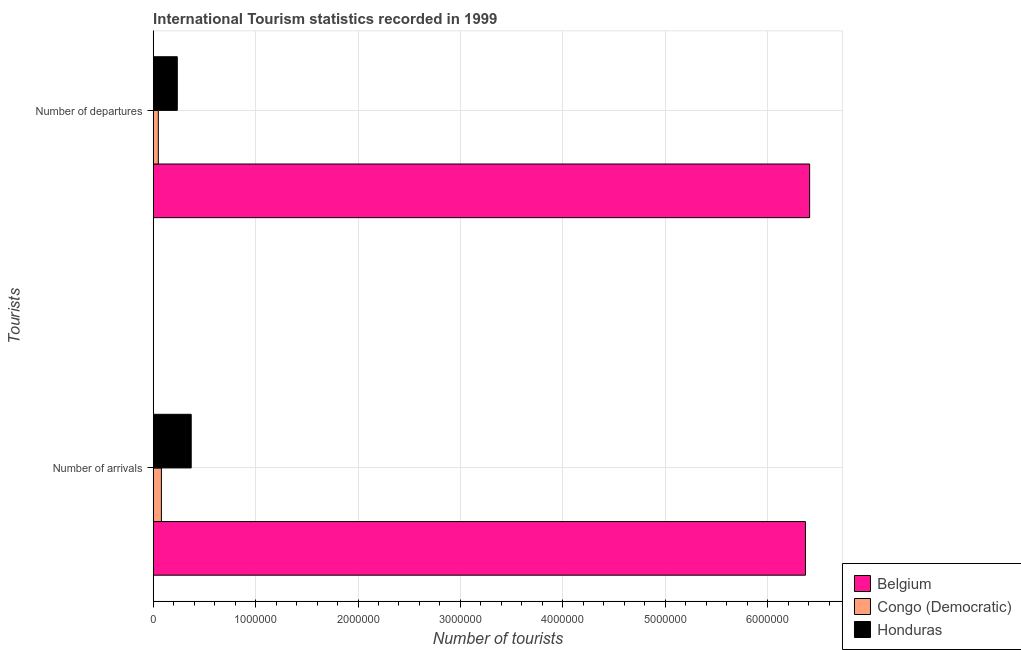How many bars are there on the 2nd tick from the top?
Offer a terse response. 3. What is the label of the 1st group of bars from the top?
Offer a very short reply. Number of departures. What is the number of tourist arrivals in Belgium?
Give a very brief answer. 6.37e+06. Across all countries, what is the maximum number of tourist arrivals?
Give a very brief answer. 6.37e+06. Across all countries, what is the minimum number of tourist departures?
Your answer should be compact. 5.00e+04. In which country was the number of tourist arrivals maximum?
Offer a very short reply. Belgium. In which country was the number of tourist departures minimum?
Ensure brevity in your answer.  Congo (Democratic). What is the total number of tourist departures in the graph?
Provide a succinct answer. 6.70e+06. What is the difference between the number of tourist arrivals in Congo (Democratic) and that in Belgium?
Keep it short and to the point. -6.29e+06. What is the difference between the number of tourist arrivals in Congo (Democratic) and the number of tourist departures in Belgium?
Keep it short and to the point. -6.33e+06. What is the average number of tourist departures per country?
Your answer should be very brief. 2.23e+06. What is the difference between the number of tourist departures and number of tourist arrivals in Congo (Democratic)?
Provide a short and direct response. -3.00e+04. In how many countries, is the number of tourist departures greater than 200000 ?
Offer a very short reply. 2. What is the ratio of the number of tourist arrivals in Congo (Democratic) to that in Belgium?
Make the answer very short. 0.01. Is the number of tourist arrivals in Honduras less than that in Belgium?
Offer a terse response. Yes. What does the 1st bar from the top in Number of departures represents?
Ensure brevity in your answer.  Honduras. What does the 3rd bar from the bottom in Number of departures represents?
Ensure brevity in your answer.  Honduras. How many bars are there?
Provide a short and direct response. 6. How many countries are there in the graph?
Give a very brief answer. 3. What is the difference between two consecutive major ticks on the X-axis?
Provide a short and direct response. 1.00e+06. Are the values on the major ticks of X-axis written in scientific E-notation?
Ensure brevity in your answer.  No. Does the graph contain grids?
Offer a terse response. Yes. Where does the legend appear in the graph?
Keep it short and to the point. Bottom right. How many legend labels are there?
Keep it short and to the point. 3. How are the legend labels stacked?
Your answer should be compact. Vertical. What is the title of the graph?
Your answer should be very brief. International Tourism statistics recorded in 1999. What is the label or title of the X-axis?
Offer a terse response. Number of tourists. What is the label or title of the Y-axis?
Keep it short and to the point. Tourists. What is the Number of tourists in Belgium in Number of arrivals?
Offer a terse response. 6.37e+06. What is the Number of tourists of Congo (Democratic) in Number of arrivals?
Ensure brevity in your answer.  8.00e+04. What is the Number of tourists of Honduras in Number of arrivals?
Provide a short and direct response. 3.71e+05. What is the Number of tourists in Belgium in Number of departures?
Provide a succinct answer. 6.41e+06. What is the Number of tourists of Honduras in Number of departures?
Give a very brief answer. 2.35e+05. Across all Tourists, what is the maximum Number of tourists of Belgium?
Make the answer very short. 6.41e+06. Across all Tourists, what is the maximum Number of tourists in Honduras?
Ensure brevity in your answer.  3.71e+05. Across all Tourists, what is the minimum Number of tourists of Belgium?
Offer a terse response. 6.37e+06. Across all Tourists, what is the minimum Number of tourists in Honduras?
Offer a very short reply. 2.35e+05. What is the total Number of tourists of Belgium in the graph?
Your answer should be compact. 1.28e+07. What is the total Number of tourists in Honduras in the graph?
Make the answer very short. 6.06e+05. What is the difference between the Number of tourists in Belgium in Number of arrivals and that in Number of departures?
Give a very brief answer. -4.10e+04. What is the difference between the Number of tourists in Congo (Democratic) in Number of arrivals and that in Number of departures?
Offer a very short reply. 3.00e+04. What is the difference between the Number of tourists in Honduras in Number of arrivals and that in Number of departures?
Keep it short and to the point. 1.36e+05. What is the difference between the Number of tourists of Belgium in Number of arrivals and the Number of tourists of Congo (Democratic) in Number of departures?
Ensure brevity in your answer.  6.32e+06. What is the difference between the Number of tourists in Belgium in Number of arrivals and the Number of tourists in Honduras in Number of departures?
Give a very brief answer. 6.13e+06. What is the difference between the Number of tourists of Congo (Democratic) in Number of arrivals and the Number of tourists of Honduras in Number of departures?
Provide a short and direct response. -1.55e+05. What is the average Number of tourists of Belgium per Tourists?
Offer a terse response. 6.39e+06. What is the average Number of tourists in Congo (Democratic) per Tourists?
Offer a terse response. 6.50e+04. What is the average Number of tourists of Honduras per Tourists?
Give a very brief answer. 3.03e+05. What is the difference between the Number of tourists in Belgium and Number of tourists in Congo (Democratic) in Number of arrivals?
Offer a terse response. 6.29e+06. What is the difference between the Number of tourists of Belgium and Number of tourists of Honduras in Number of arrivals?
Make the answer very short. 6.00e+06. What is the difference between the Number of tourists in Congo (Democratic) and Number of tourists in Honduras in Number of arrivals?
Provide a succinct answer. -2.91e+05. What is the difference between the Number of tourists of Belgium and Number of tourists of Congo (Democratic) in Number of departures?
Offer a terse response. 6.36e+06. What is the difference between the Number of tourists in Belgium and Number of tourists in Honduras in Number of departures?
Ensure brevity in your answer.  6.18e+06. What is the difference between the Number of tourists of Congo (Democratic) and Number of tourists of Honduras in Number of departures?
Offer a terse response. -1.85e+05. What is the ratio of the Number of tourists of Belgium in Number of arrivals to that in Number of departures?
Provide a succinct answer. 0.99. What is the ratio of the Number of tourists in Honduras in Number of arrivals to that in Number of departures?
Offer a very short reply. 1.58. What is the difference between the highest and the second highest Number of tourists of Belgium?
Ensure brevity in your answer.  4.10e+04. What is the difference between the highest and the second highest Number of tourists of Honduras?
Keep it short and to the point. 1.36e+05. What is the difference between the highest and the lowest Number of tourists in Belgium?
Ensure brevity in your answer.  4.10e+04. What is the difference between the highest and the lowest Number of tourists of Congo (Democratic)?
Ensure brevity in your answer.  3.00e+04. What is the difference between the highest and the lowest Number of tourists of Honduras?
Offer a very short reply. 1.36e+05. 